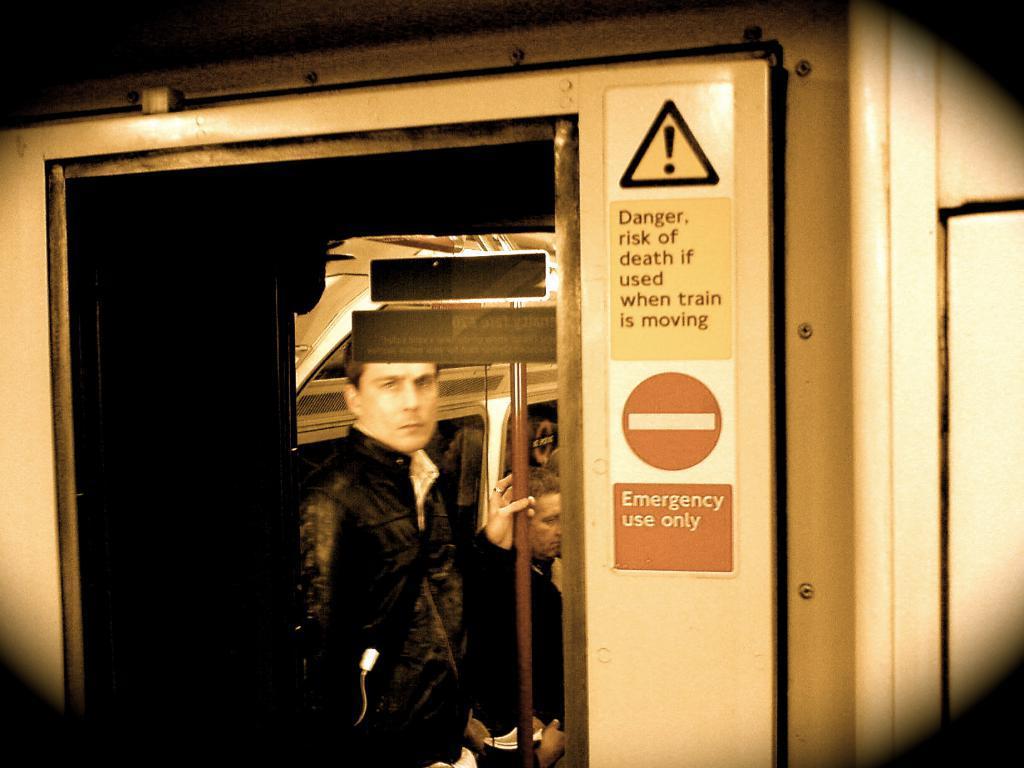How would you summarize this image in a sentence or two? In this picture we observe a guy who is inside a metro train and in the background we observe Danger and Fire exit labels attached. 